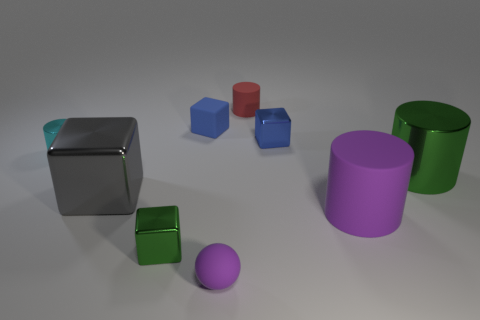How many big gray things are there?
Your answer should be very brief. 1. What shape is the big shiny thing that is to the left of the green shiny thing that is to the left of the blue rubber block?
Offer a terse response. Cube. There is a cyan cylinder; how many purple rubber things are to the left of it?
Your response must be concise. 0. Does the large gray object have the same material as the large cylinder that is in front of the large green metal object?
Give a very brief answer. No. Are there any green metallic objects that have the same size as the red rubber thing?
Your answer should be very brief. Yes. Is the number of metal cylinders in front of the gray metallic cube the same as the number of gray cubes?
Keep it short and to the point. No. What size is the rubber ball?
Your answer should be very brief. Small. What number of metallic things are right of the green metal object on the left side of the tiny red rubber cylinder?
Keep it short and to the point. 2. What shape is the small metal object that is to the left of the small blue rubber block and on the right side of the cyan metal cylinder?
Offer a very short reply. Cube. How many spheres have the same color as the large matte cylinder?
Offer a terse response. 1. 